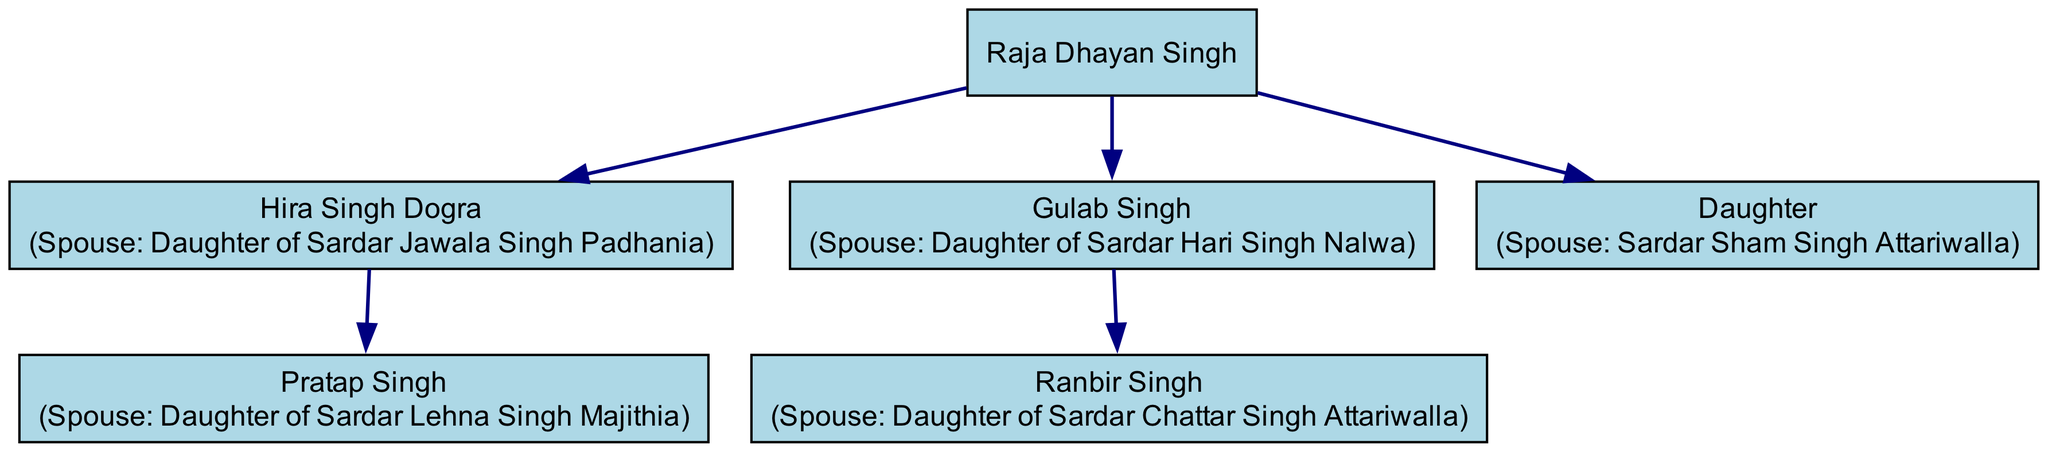What is the name of Raja Dhayan Singh's first child? The diagram shows that Raja Dhayan Singh has three children listed: Hira Singh Dogra, Gulab Singh, and a Daughter. The first child mentioned is Hira Singh Dogra.
Answer: Hira Singh Dogra How many children does Hira Singh Dogra have? According to the diagram, Hira Singh Dogra has one child, Pratap Singh. Therefore, counting this child, Hira Singh Dogra has a total of one child.
Answer: 1 Who is the spouse of Ranbir Singh? The diagram shows that Ranbir Singh is married to the Daughter of Sardar Chattar Singh Attariwalla. Therefore, the spouse of Ranbir Singh is specifically referred to as "Daughter of Sardar Chattar Singh Attariwalla."
Answer: Daughter of Sardar Chattar Singh Attariwalla What is the relationship between Gulab Singh and the Daughter? The diagram indicates that Gulab Singh and the Daughter are both children of Raja Dhayan Singh. Thus, they are siblings.
Answer: Siblings How many prominent Punjabi noble houses are represented in the marriages of Raja Dhayan Singh's children? The diagram illustrates that Raja Dhayan Singh's children have intermarried with four prominent Punjabi noble houses, including Padhania, Majithia, Nalwa, and Attariwalla. Thus, by counting these houses, we find that there are four distinct noble houses represented.
Answer: 4 Which noble house is associated with Hira Singh Dogra's spouse? The diagram specifies that Hira Singh Dogra's spouse is from the house of Sardar Jawala Singh Padhania. Therefore, the noble house associated with Hira Singh Dogra's spouse is Padhania.
Answer: Padhania What is the connection between Gulab Singh's family and Chattar Singh Attariwalla? The diagram indicates that Gulab Singh's child, Ranbir Singh, is married to the Daughter of Sardar Chattar Singh Attariwalla. This implies that there is a marriage connection between Gulab Singh's family and the Attariwalla house.
Answer: Marriage connection How many nodes are present in the diagram? The diagram includes a total of six nodes: Raja Dhayan Singh, Hira Singh Dogra, Gulab Singh, Daughter, Pratap Singh, and Ranbir Singh. By counting them, we determine the total number of nodes present in the diagram.
Answer: 6 Who are the children of Gulab Singh? The diagram indicates that Gulab Singh has one child, who is Ranbir Singh. Therefore, the children of Gulab Singh consist solely of Ranbir Singh.
Answer: Ranbir Singh 